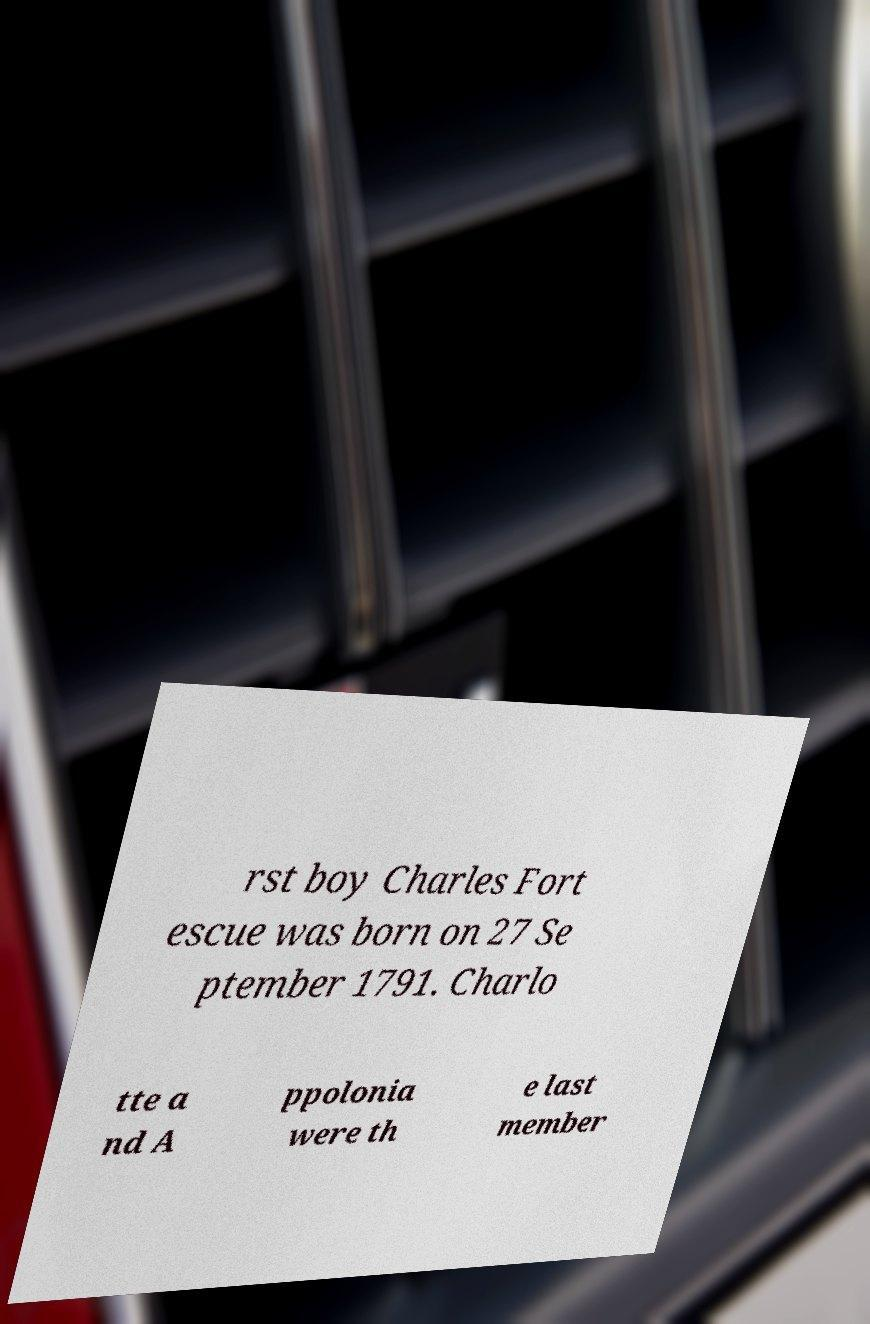Could you assist in decoding the text presented in this image and type it out clearly? rst boy Charles Fort escue was born on 27 Se ptember 1791. Charlo tte a nd A ppolonia were th e last member 